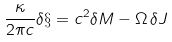Convert formula to latex. <formula><loc_0><loc_0><loc_500><loc_500>\frac { \kappa } { 2 \pi c } \delta \S = c ^ { 2 } \delta M - \Omega \, \delta J</formula> 